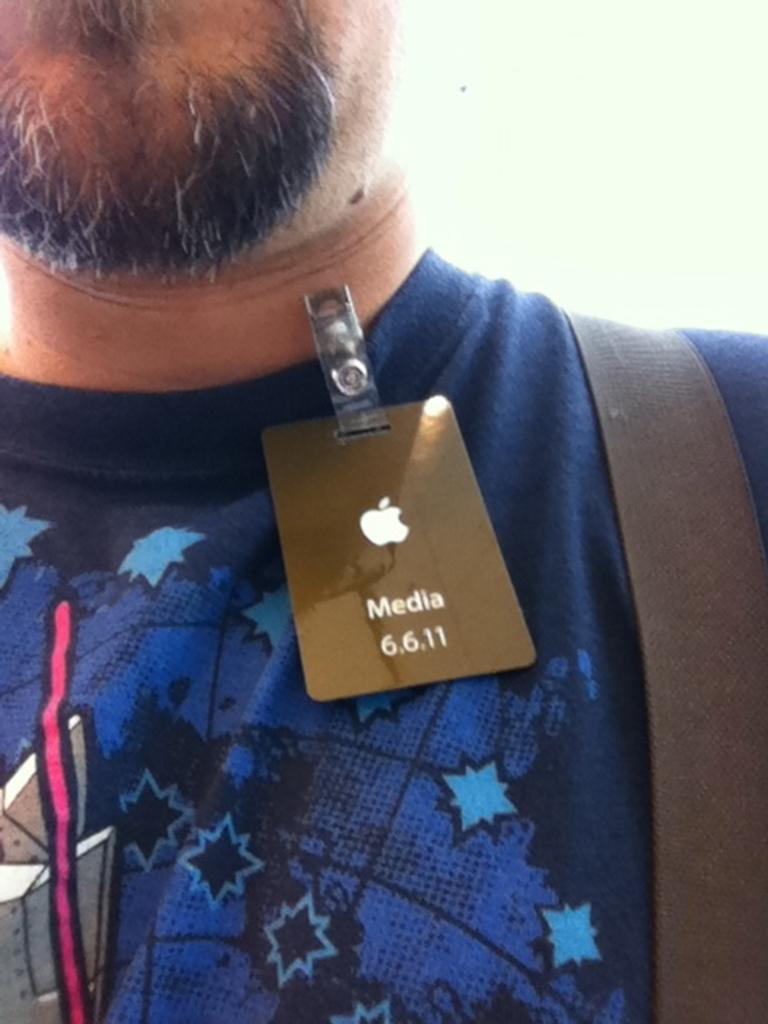Who is present in the image? There is a man in the image. What is the man wearing? The man is wearing a blue t-shirt. Are there any distinguishing features on the t-shirt? Yes, there is a badge on the t-shirt. Is there anything else on the t-shirt besides the badge? Yes, there is an item on the t-shirt. What type of string is the man using to express his hate in the image? There is no string or expression of hate present in the image. 